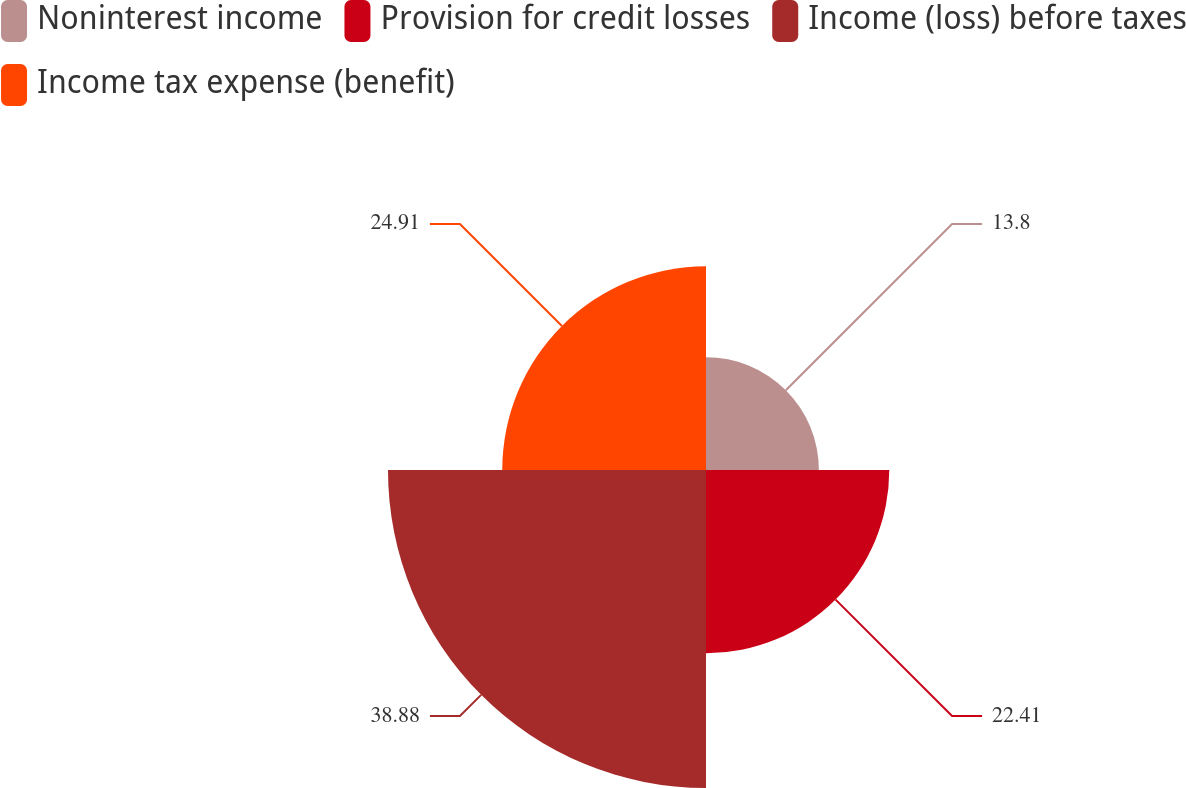Convert chart to OTSL. <chart><loc_0><loc_0><loc_500><loc_500><pie_chart><fcel>Noninterest income<fcel>Provision for credit losses<fcel>Income (loss) before taxes<fcel>Income tax expense (benefit)<nl><fcel>13.8%<fcel>22.41%<fcel>38.88%<fcel>24.91%<nl></chart> 